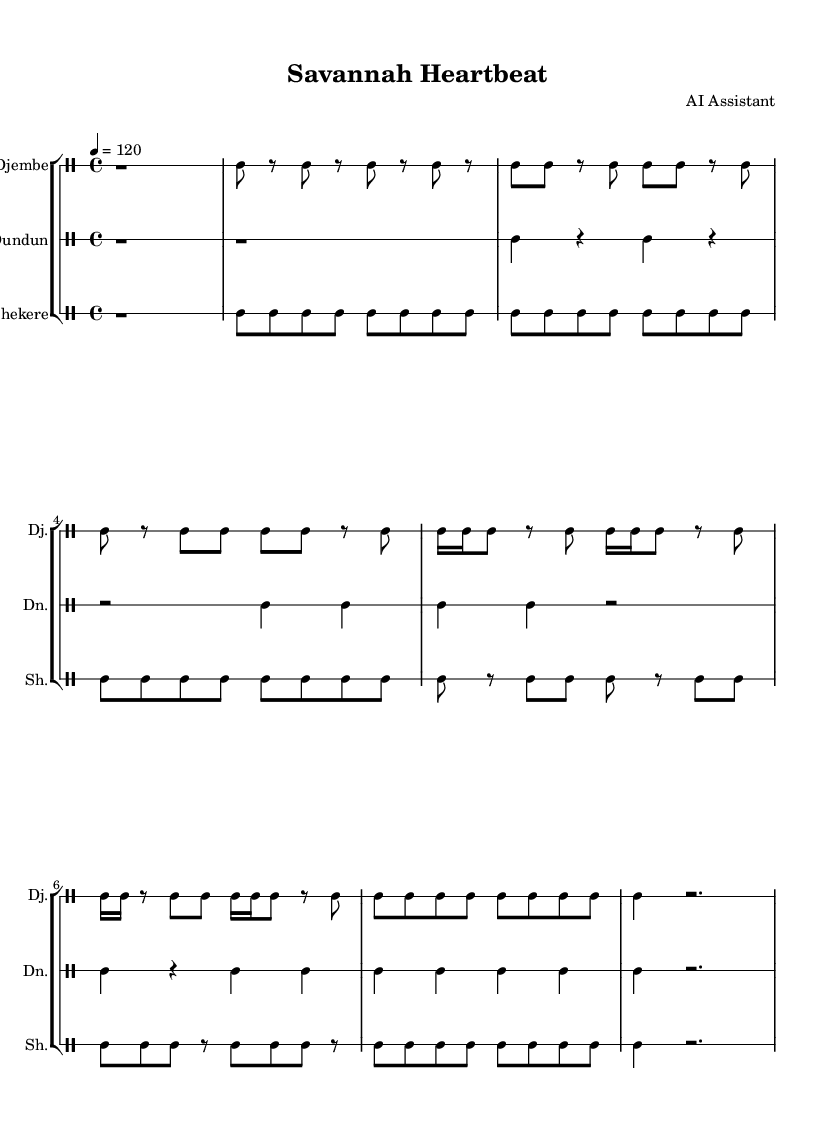What is the key signature of this music? The key signature is C major, which has no sharps or flats.
Answer: C major What is the time signature of this piece? The time signature is seen at the beginning of the score and is indicated as 4/4, meaning there are four beats in each measure.
Answer: 4/4 What is the tempo marking provided in the score? The tempo marking appears over the staff and indicates a speed of quarter note equals 120 beats per minute.
Answer: 120 How many instruments are used in this score? There are three distinct drum parts: Djembe, Dundun, and Shekere, all represented in separate staves.
Answer: Three Which instrument plays the main rhythm in the intro section? The Djembe starts with a rest followed by a short rhythm pattern of bass drum notes and rests for the intro.
Answer: Djembe How does the Shekere's main theme differ from the Djembe's main theme? Analyzing the patterns, the Shekere plays a consistent series of short notes while the Djembe has a variable pattern with more rests, indicating rhythmic complexity.
Answer: Consistent short notes What rhythmic variation is present in the Djembe section? The Djembe section features a rhythmic change in the variation with sixteenth notes introduced, altering the flow of the rhythm compared to the main theme.
Answer: Sixteenth notes 